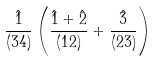Convert formula to latex. <formula><loc_0><loc_0><loc_500><loc_500>\frac { \hat { 1 } } { ( 3 4 ) } \left ( \frac { \hat { 1 } + \hat { 2 } } { ( 1 2 ) } + \frac { \hat { 3 } } { ( 2 3 ) } \right )</formula> 